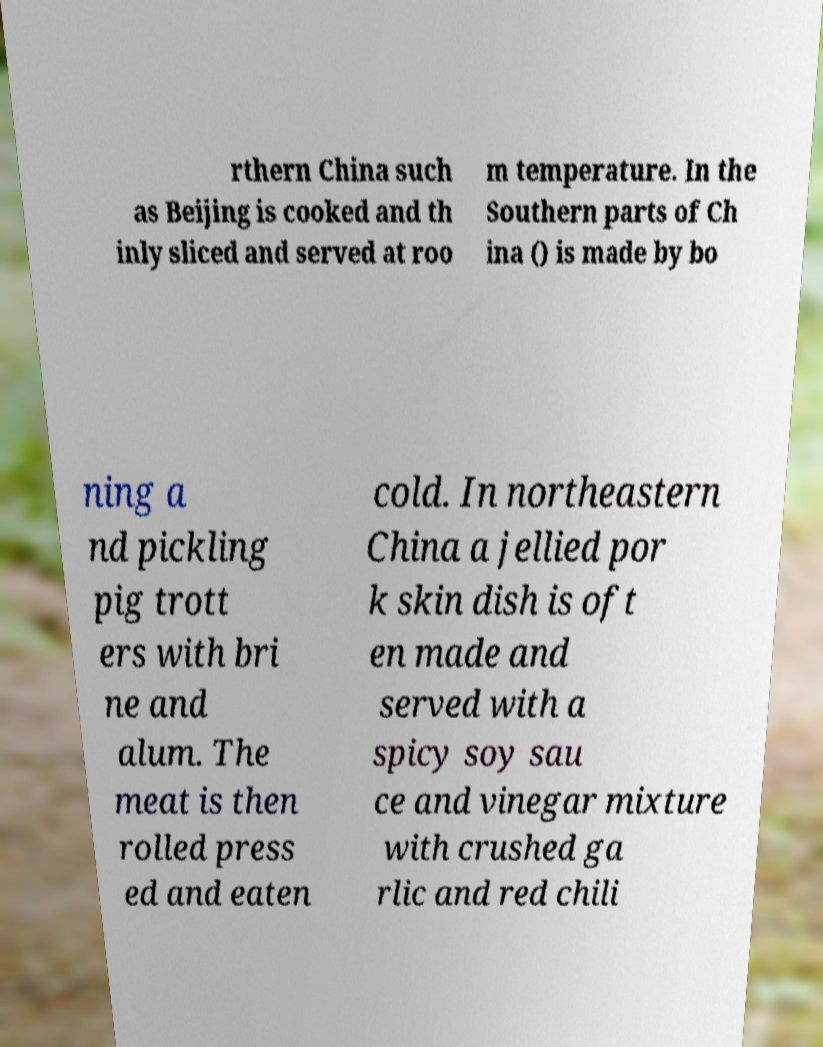Please read and relay the text visible in this image. What does it say? rthern China such as Beijing is cooked and th inly sliced and served at roo m temperature. In the Southern parts of Ch ina () is made by bo ning a nd pickling pig trott ers with bri ne and alum. The meat is then rolled press ed and eaten cold. In northeastern China a jellied por k skin dish is oft en made and served with a spicy soy sau ce and vinegar mixture with crushed ga rlic and red chili 